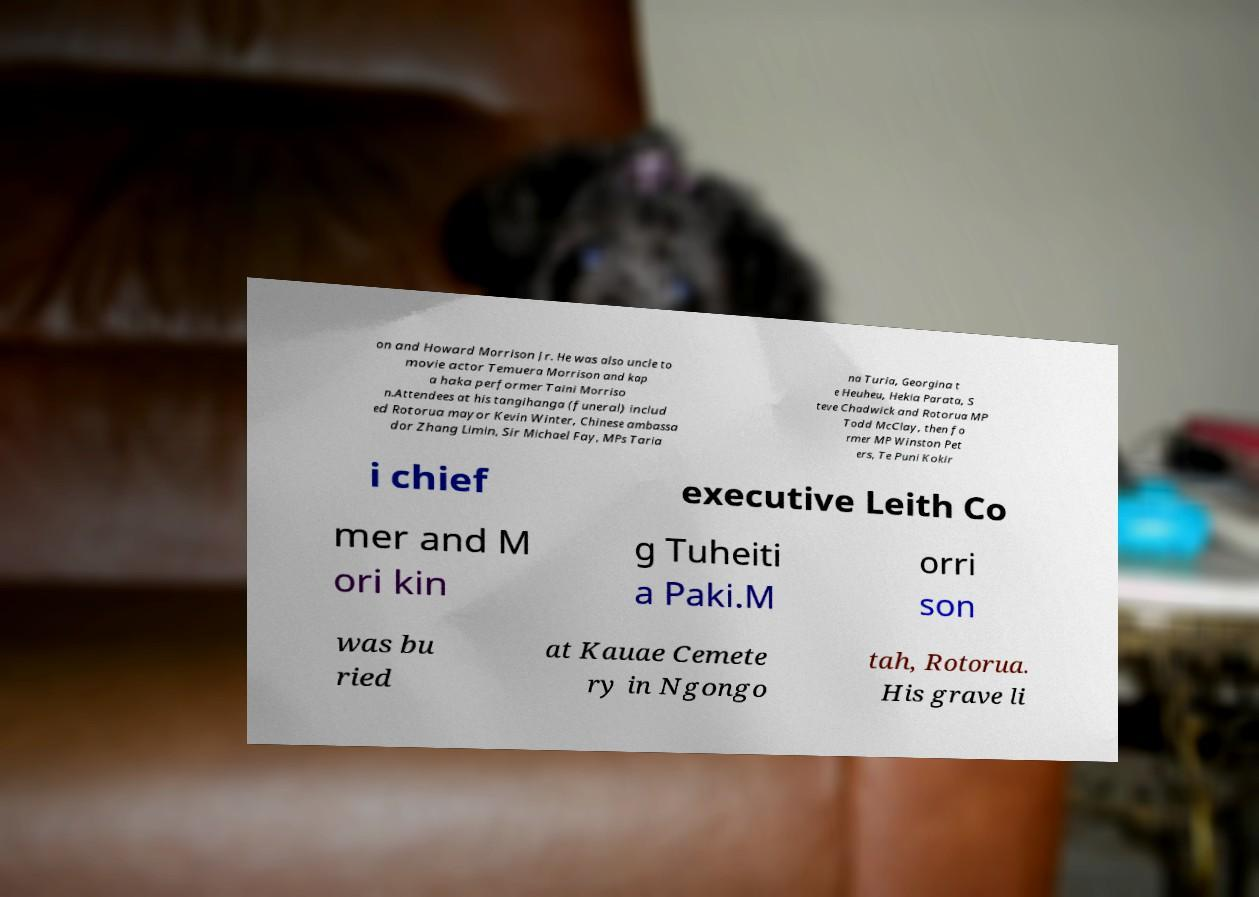What messages or text are displayed in this image? I need them in a readable, typed format. on and Howard Morrison Jr. He was also uncle to movie actor Temuera Morrison and kap a haka performer Taini Morriso n.Attendees at his tangihanga (funeral) includ ed Rotorua mayor Kevin Winter, Chinese ambassa dor Zhang Limin, Sir Michael Fay, MPs Taria na Turia, Georgina t e Heuheu, Hekia Parata, S teve Chadwick and Rotorua MP Todd McClay, then fo rmer MP Winston Pet ers, Te Puni Kokir i chief executive Leith Co mer and M ori kin g Tuheiti a Paki.M orri son was bu ried at Kauae Cemete ry in Ngongo tah, Rotorua. His grave li 